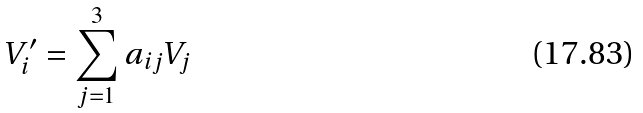<formula> <loc_0><loc_0><loc_500><loc_500>V _ { i } ^ { \prime } = \sum _ { j = 1 } ^ { 3 } a _ { i j } V _ { j }</formula> 